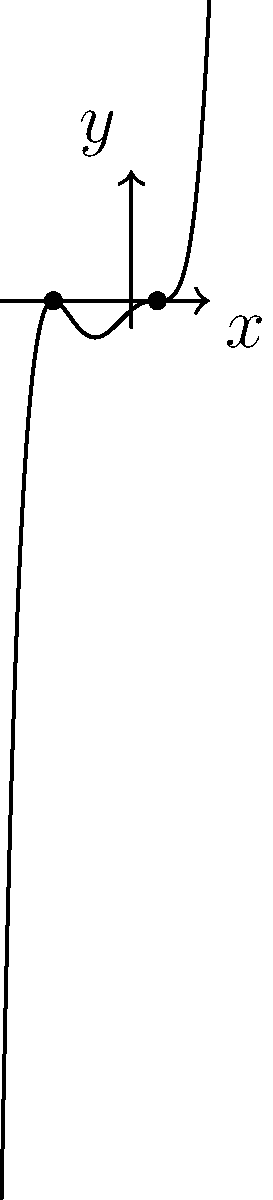Given the polynomial graph above, determine the multiplicity of the root at $x=-3$ and $x=1$. Express your answer as an ordered pair $(a,b)$, where $a$ is the multiplicity of the root at $x=-3$ and $b$ is the multiplicity of the root at $x=1$. To determine the multiplicity of roots from a polynomial graph, we need to analyze how the graph behaves near each root:

1. For the root at $x=-3$:
   - The graph touches the x-axis and bounces off immediately.
   - This behavior indicates a multiplicity of 2 (even number).

2. For the root at $x=1$:
   - The graph crosses the x-axis and continues in the same direction.
   - The curve appears to have a horizontal tangent at this point.
   - This behavior suggests a multiplicity of 3 (odd number greater than 1).

3. We can confirm these observations by noting that:
   - Even multiplicities result in the graph touching and bouncing off the x-axis.
   - Odd multiplicities greater than 1 result in the graph crossing the x-axis with a horizontal tangent.

Therefore, the multiplicity of the root at $x=-3$ is 2, and the multiplicity of the root at $x=1$ is 3.
Answer: $(2,3)$ 